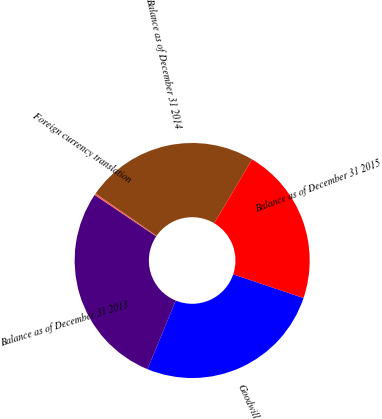Convert chart to OTSL. <chart><loc_0><loc_0><loc_500><loc_500><pie_chart><fcel>Goodwill<fcel>Balance as of December 31 2013<fcel>Foreign currency translation<fcel>Balance as of December 31 2014<fcel>Balance as of December 31 2015<nl><fcel>26.03%<fcel>28.22%<fcel>0.23%<fcel>23.85%<fcel>21.66%<nl></chart> 